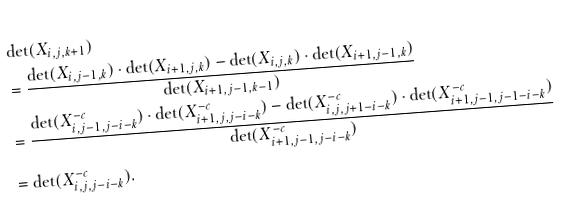Convert formula to latex. <formula><loc_0><loc_0><loc_500><loc_500>& \det ( X _ { i , j , k + 1 } ) \\ & = \frac { \det ( X _ { i , j - 1 , k } ) \cdot \det ( X _ { i + 1 , j , k } ) - \det ( X _ { i , j , k } ) \cdot \det ( X _ { i + 1 , j - 1 , k } ) } { \det ( X _ { i + 1 , j - 1 , k - 1 } ) } \\ & = \frac { \det ( X ^ { - c } _ { i , j - 1 , j - i - k } ) \cdot \det ( X ^ { - c } _ { i + 1 , j , j - i - k } ) - \det ( X ^ { - c } _ { i , j , j + 1 - i - k } ) \cdot \det ( X ^ { - c } _ { i + 1 , j - 1 , j - 1 - i - k } ) } { \det ( X ^ { - c } _ { i + 1 , j - 1 , j - i - k } ) } \\ & = \det ( X ^ { - c } _ { i , j , j - i - k } ) .</formula> 